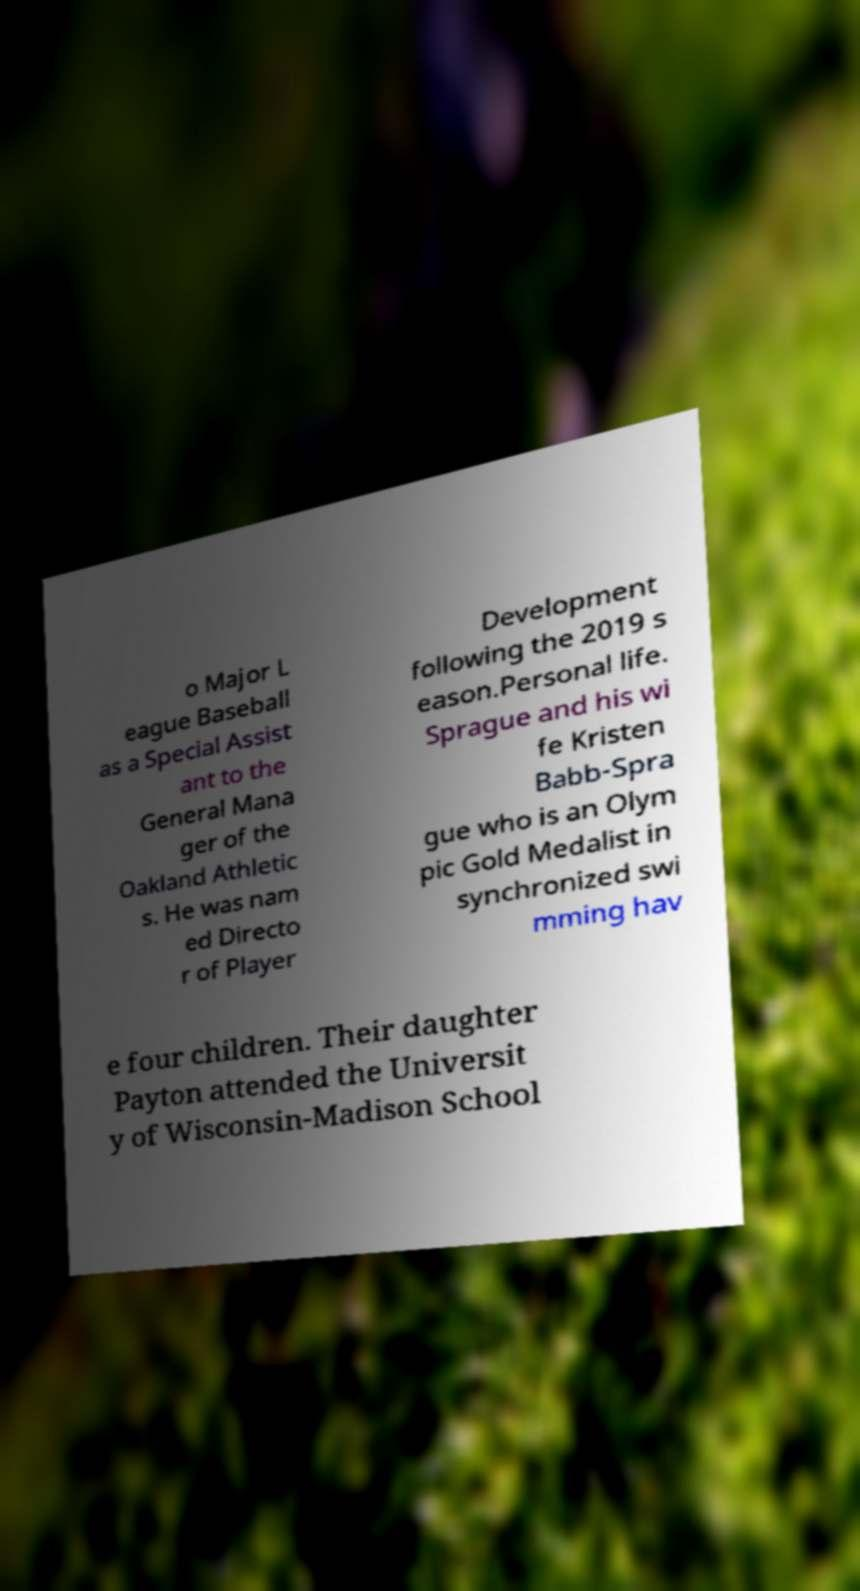Could you extract and type out the text from this image? o Major L eague Baseball as a Special Assist ant to the General Mana ger of the Oakland Athletic s. He was nam ed Directo r of Player Development following the 2019 s eason.Personal life. Sprague and his wi fe Kristen Babb-Spra gue who is an Olym pic Gold Medalist in synchronized swi mming hav e four children. Their daughter Payton attended the Universit y of Wisconsin-Madison School 